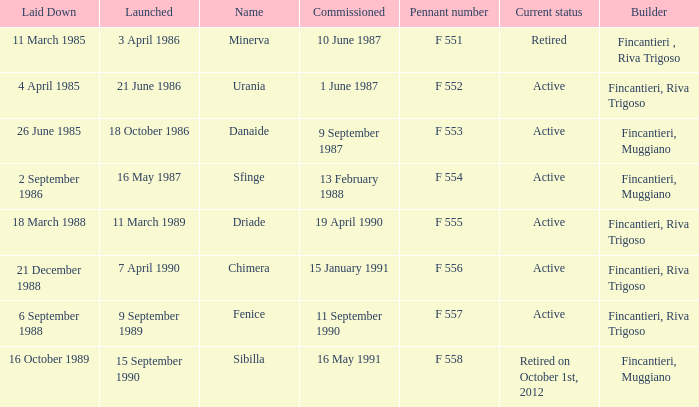Give me the full table as a dictionary. {'header': ['Laid Down', 'Launched', 'Name', 'Commissioned', 'Pennant number', 'Current status', 'Builder'], 'rows': [['11 March 1985', '3 April 1986', 'Minerva', '10 June 1987', 'F 551', 'Retired', 'Fincantieri , Riva Trigoso'], ['4 April 1985', '21 June 1986', 'Urania', '1 June 1987', 'F 552', 'Active', 'Fincantieri, Riva Trigoso'], ['26 June 1985', '18 October 1986', 'Danaide', '9 September 1987', 'F 553', 'Active', 'Fincantieri, Muggiano'], ['2 September 1986', '16 May 1987', 'Sfinge', '13 February 1988', 'F 554', 'Active', 'Fincantieri, Muggiano'], ['18 March 1988', '11 March 1989', 'Driade', '19 April 1990', 'F 555', 'Active', 'Fincantieri, Riva Trigoso'], ['21 December 1988', '7 April 1990', 'Chimera', '15 January 1991', 'F 556', 'Active', 'Fincantieri, Riva Trigoso'], ['6 September 1988', '9 September 1989', 'Fenice', '11 September 1990', 'F 557', 'Active', 'Fincantieri, Riva Trigoso'], ['16 October 1989', '15 September 1990', 'Sibilla', '16 May 1991', 'F 558', 'Retired on October 1st, 2012', 'Fincantieri, Muggiano']]} What is the name of the builder who launched in danaide 18 October 1986. 